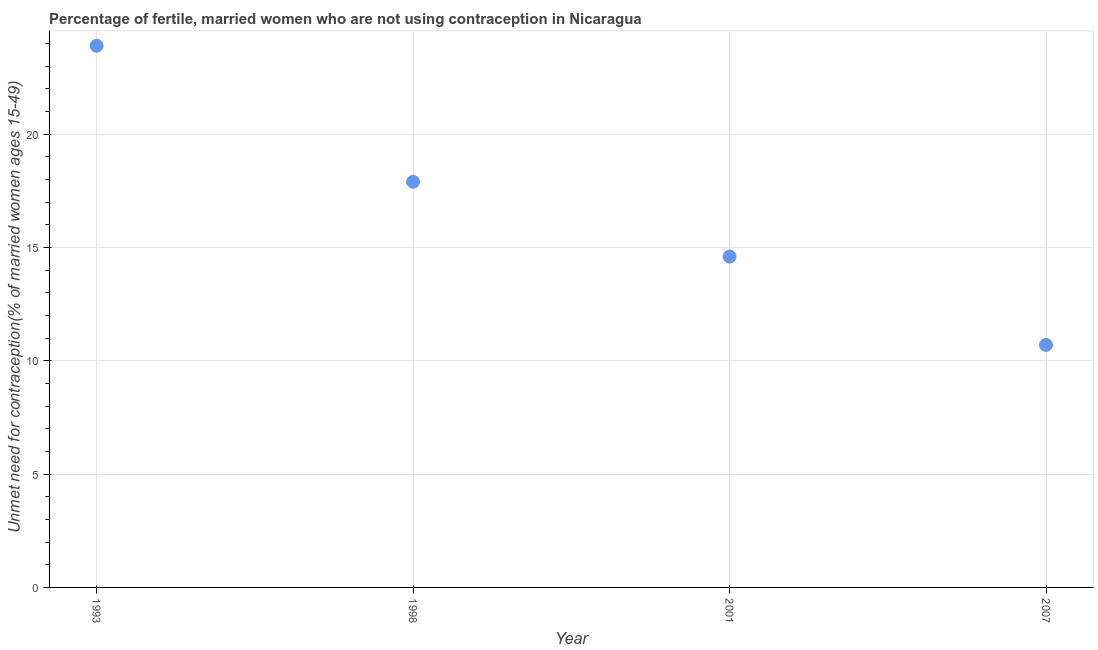What is the number of married women who are not using contraception in 2007?
Offer a terse response. 10.7. Across all years, what is the maximum number of married women who are not using contraception?
Provide a short and direct response. 23.9. Across all years, what is the minimum number of married women who are not using contraception?
Ensure brevity in your answer.  10.7. What is the sum of the number of married women who are not using contraception?
Offer a terse response. 67.1. What is the difference between the number of married women who are not using contraception in 1998 and 2007?
Your answer should be compact. 7.2. What is the average number of married women who are not using contraception per year?
Your answer should be compact. 16.77. What is the median number of married women who are not using contraception?
Your answer should be compact. 16.25. Do a majority of the years between 2001 and 1998 (inclusive) have number of married women who are not using contraception greater than 18 %?
Offer a very short reply. No. What is the ratio of the number of married women who are not using contraception in 1998 to that in 2001?
Your response must be concise. 1.23. Is the number of married women who are not using contraception in 1998 less than that in 2007?
Ensure brevity in your answer.  No. Is the difference between the number of married women who are not using contraception in 1993 and 2001 greater than the difference between any two years?
Your response must be concise. No. What is the difference between the highest and the second highest number of married women who are not using contraception?
Provide a short and direct response. 6. Does the number of married women who are not using contraception monotonically increase over the years?
Keep it short and to the point. No. How many dotlines are there?
Your response must be concise. 1. Does the graph contain any zero values?
Offer a terse response. No. Does the graph contain grids?
Make the answer very short. Yes. What is the title of the graph?
Provide a succinct answer. Percentage of fertile, married women who are not using contraception in Nicaragua. What is the label or title of the X-axis?
Make the answer very short. Year. What is the label or title of the Y-axis?
Your answer should be compact.  Unmet need for contraception(% of married women ages 15-49). What is the  Unmet need for contraception(% of married women ages 15-49) in 1993?
Your answer should be compact. 23.9. What is the  Unmet need for contraception(% of married women ages 15-49) in 1998?
Keep it short and to the point. 17.9. What is the  Unmet need for contraception(% of married women ages 15-49) in 2001?
Keep it short and to the point. 14.6. What is the difference between the  Unmet need for contraception(% of married women ages 15-49) in 1993 and 1998?
Offer a terse response. 6. What is the difference between the  Unmet need for contraception(% of married women ages 15-49) in 1993 and 2001?
Your answer should be very brief. 9.3. What is the difference between the  Unmet need for contraception(% of married women ages 15-49) in 1993 and 2007?
Provide a succinct answer. 13.2. What is the difference between the  Unmet need for contraception(% of married women ages 15-49) in 1998 and 2007?
Offer a very short reply. 7.2. What is the difference between the  Unmet need for contraception(% of married women ages 15-49) in 2001 and 2007?
Offer a very short reply. 3.9. What is the ratio of the  Unmet need for contraception(% of married women ages 15-49) in 1993 to that in 1998?
Provide a short and direct response. 1.33. What is the ratio of the  Unmet need for contraception(% of married women ages 15-49) in 1993 to that in 2001?
Make the answer very short. 1.64. What is the ratio of the  Unmet need for contraception(% of married women ages 15-49) in 1993 to that in 2007?
Keep it short and to the point. 2.23. What is the ratio of the  Unmet need for contraception(% of married women ages 15-49) in 1998 to that in 2001?
Ensure brevity in your answer.  1.23. What is the ratio of the  Unmet need for contraception(% of married women ages 15-49) in 1998 to that in 2007?
Offer a terse response. 1.67. What is the ratio of the  Unmet need for contraception(% of married women ages 15-49) in 2001 to that in 2007?
Provide a short and direct response. 1.36. 